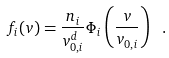Convert formula to latex. <formula><loc_0><loc_0><loc_500><loc_500>f _ { i } ( v ) = \frac { n _ { i } } { v _ { 0 , i } ^ { d } } \Phi _ { i } \left ( \frac { v } { v _ { 0 , i } } \right ) \ .</formula> 